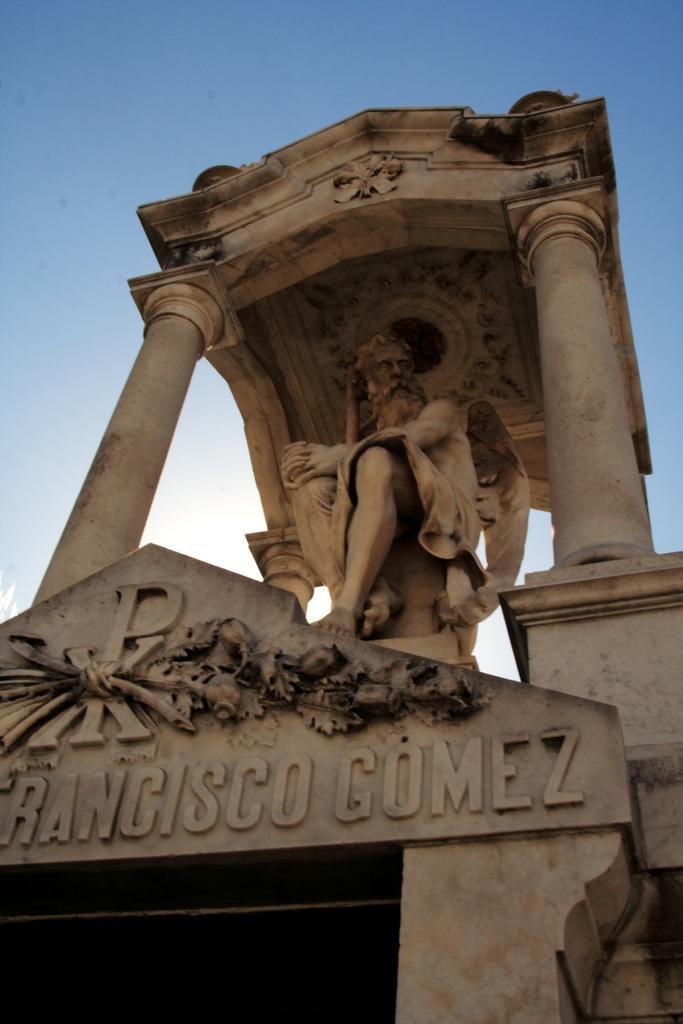Could you give a brief overview of what you see in this image? In the picture I can see a statue of a person and there is something written below it. 